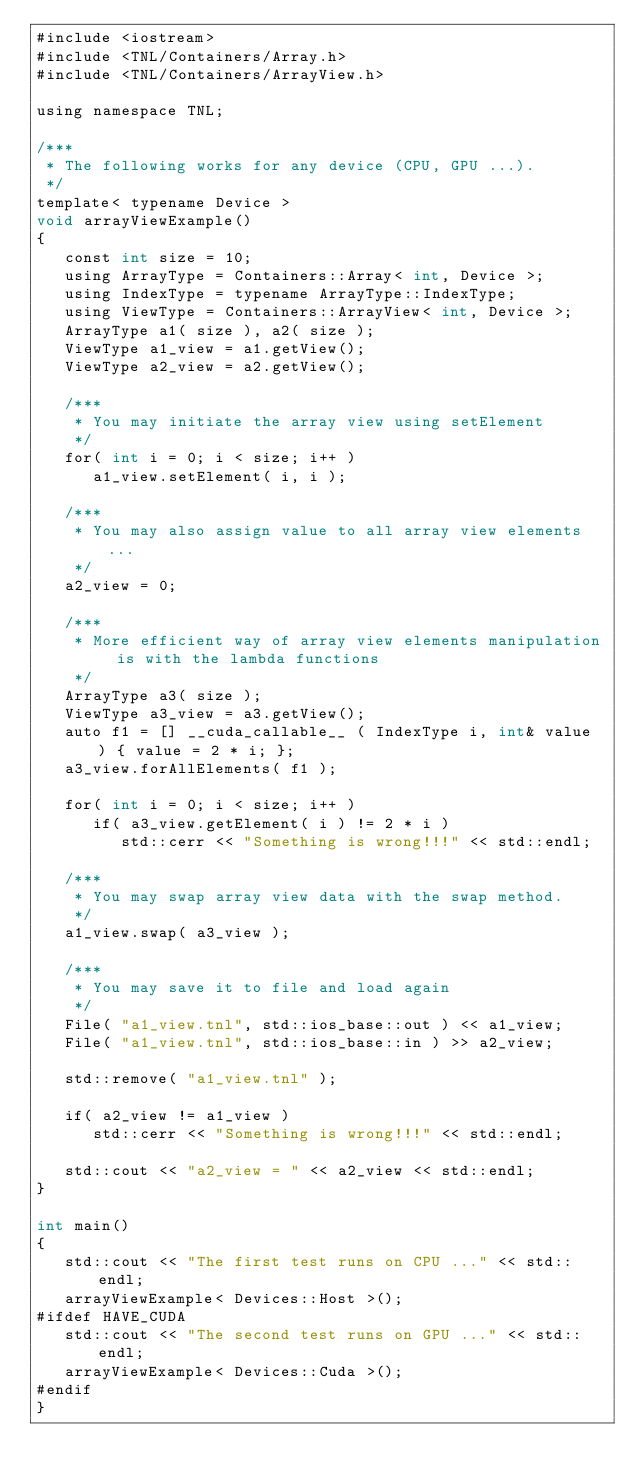<code> <loc_0><loc_0><loc_500><loc_500><_Cuda_>#include <iostream>
#include <TNL/Containers/Array.h>
#include <TNL/Containers/ArrayView.h>

using namespace TNL;

/***
 * The following works for any device (CPU, GPU ...).
 */
template< typename Device >
void arrayViewExample()
{
   const int size = 10;
   using ArrayType = Containers::Array< int, Device >;
   using IndexType = typename ArrayType::IndexType;
   using ViewType = Containers::ArrayView< int, Device >;
   ArrayType a1( size ), a2( size );
   ViewType a1_view = a1.getView();
   ViewType a2_view = a2.getView();

   /***
    * You may initiate the array view using setElement
    */
   for( int i = 0; i < size; i++ )
      a1_view.setElement( i, i );

   /***
    * You may also assign value to all array view elements ...
    */
   a2_view = 0;

   /***
    * More efficient way of array view elements manipulation is with the lambda functions
    */
   ArrayType a3( size );
   ViewType a3_view = a3.getView();
   auto f1 = [] __cuda_callable__ ( IndexType i, int& value ) { value = 2 * i; };
   a3_view.forAllElements( f1 );

   for( int i = 0; i < size; i++ )
      if( a3_view.getElement( i ) != 2 * i )
         std::cerr << "Something is wrong!!!" << std::endl;

   /***
    * You may swap array view data with the swap method.
    */
   a1_view.swap( a3_view );

   /***
    * You may save it to file and load again
    */
   File( "a1_view.tnl", std::ios_base::out ) << a1_view;
   File( "a1_view.tnl", std::ios_base::in ) >> a2_view;

   std::remove( "a1_view.tnl" );

   if( a2_view != a1_view )
      std::cerr << "Something is wrong!!!" << std::endl;

   std::cout << "a2_view = " << a2_view << std::endl;
}

int main()
{
   std::cout << "The first test runs on CPU ..." << std::endl;
   arrayViewExample< Devices::Host >();
#ifdef HAVE_CUDA
   std::cout << "The second test runs on GPU ..." << std::endl;
   arrayViewExample< Devices::Cuda >();
#endif
}
</code> 